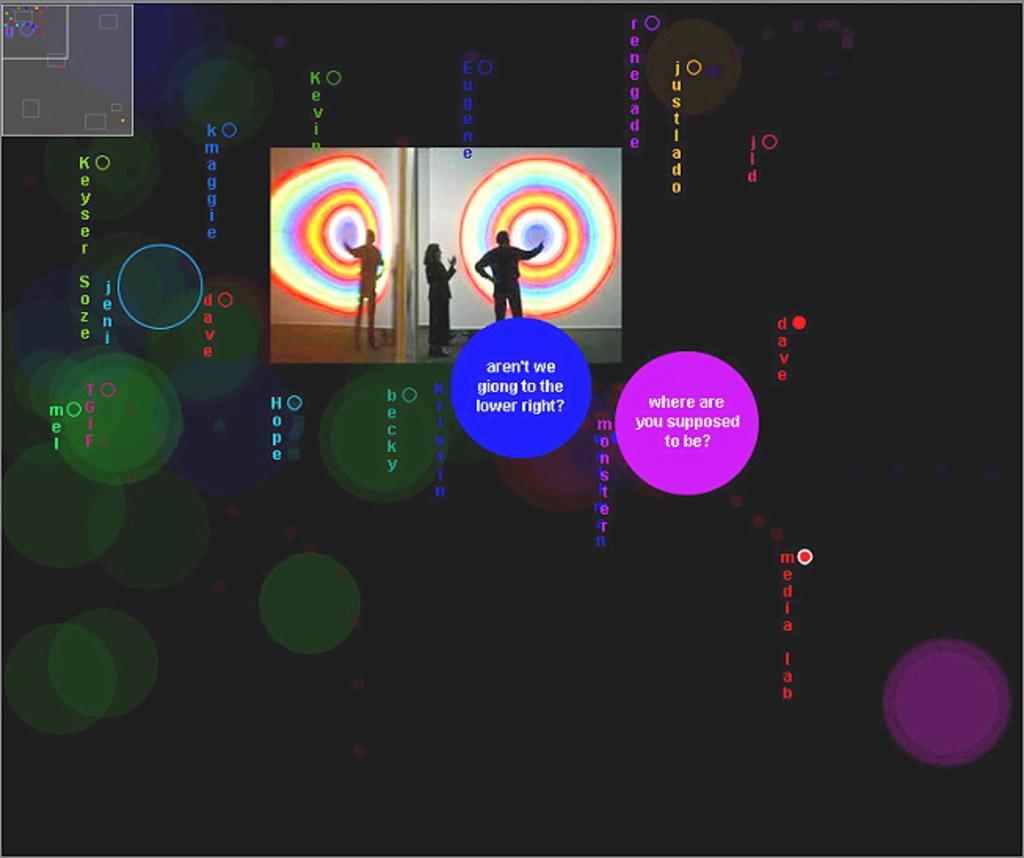Could you give a brief overview of what you see in this image? In this image I can see two people standing. In front I can see a colorful circles. I can see a purple,blue,green color circle and something is written on it. Background is in black color. 